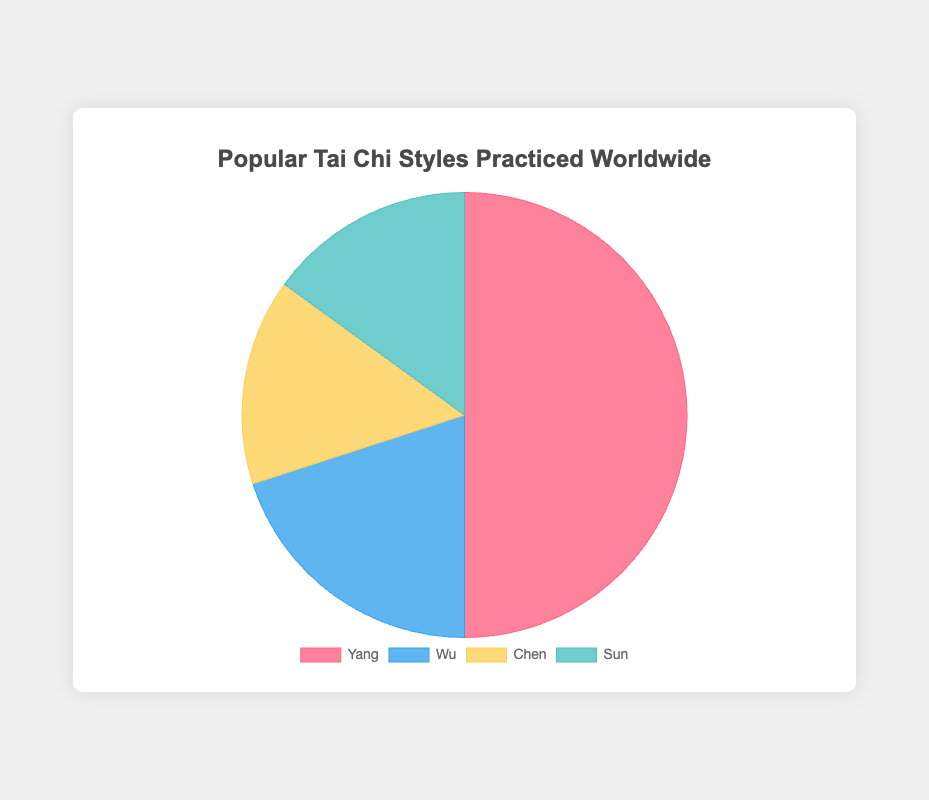What percentage of practitioners practice the Yang style compared to the total number of practitioners? The figure shows that Yang style practitioners make up 50% of the total. Since the pie chart represents the total data and the Yang segment is 50%, the percentage of Yang style practitioners is 50%.
Answer: 50% Which two Tai Chi styles have an equal number of practitioners? The pie chart reveals that both the Chen and Sun styles have a slice of equal size, each representing 15 practitioners, indicating that the number of practitioners for these two styles is equal.
Answer: Chen and Sun What is the total percentage of practitioners for Chen and Sun Tai Chi styles combined? The pie chart shows that the Chen and Sun styles each make up 15%, adding these gives 15% + 15% = 30%.
Answer: 30% Which Tai Chi style has the smallest percentage of practitioners and what is that percentage? The pie chart shows that both Chen and Sun styles have the smallest slices, each with 15%.
Answer: Chen and Sun, 15% Which style has more practitioners, Wu or Chen? The pie chart shows a larger slice for the Wu style (20%) compared to the Chen style (15%), indicating that Wu has more practitioners.
Answer: Wu How much larger is the percentage of practitioners for Yang style than for the Wu style? The pie chart shows Yang at 50% and Wu at 20%, subtracting these percentages gives 50% - 20% = 30%.
Answer: 30% What is the total number of practitioners represented in the pie chart? Adding up the practitioners: 50 (Yang) + 20 (Wu) + 15 (Chen) + 15 (Sun) = 100.
Answer: 100 If you wanted to practice a style that is less common than Wu but more common than Chen, which style would you choose? The pie chart shows Wu at 20%, Chen at 15%, and Sun also at 15%. There's no style between Wu and Chen percentages.
Answer: None What fraction of the total Tai Chi practitioners practice the Sun style? The Sun style has 15% of the total practitioners. This can be represented as a fraction: 15/100 = 3/20.
Answer: 3/20 By how much does the percentage of practitioners for Yang style exceed the combined percentage of Chen and Sun styles? The pie chart shows Yang at 50%, while Chen and Sun together are 15% + 15% = 30%. Subtracting these gives 50% - 30% = 20%.
Answer: 20% 